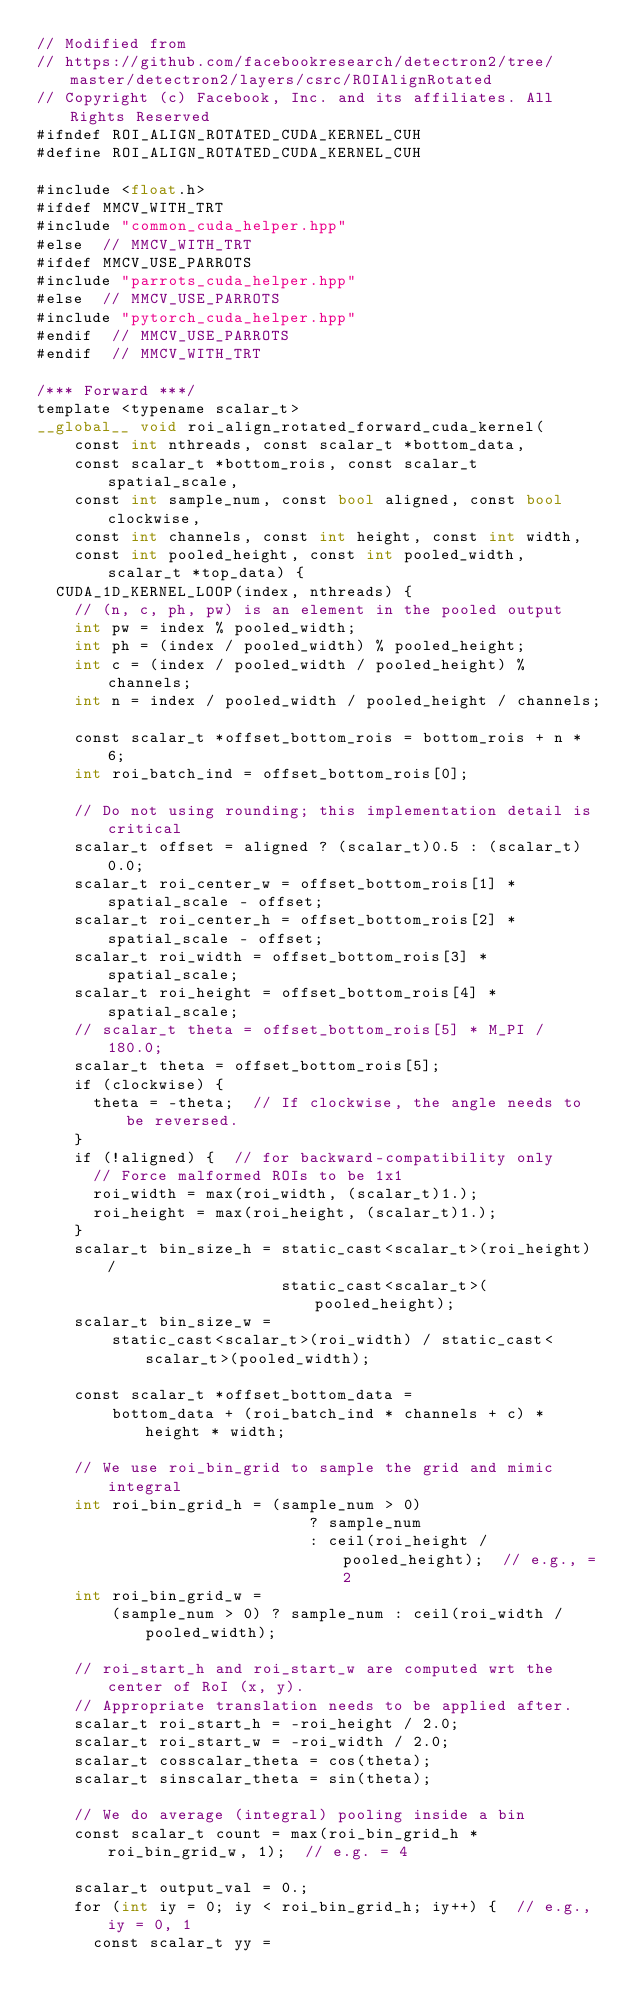Convert code to text. <code><loc_0><loc_0><loc_500><loc_500><_Cuda_>// Modified from
// https://github.com/facebookresearch/detectron2/tree/master/detectron2/layers/csrc/ROIAlignRotated
// Copyright (c) Facebook, Inc. and its affiliates. All Rights Reserved
#ifndef ROI_ALIGN_ROTATED_CUDA_KERNEL_CUH
#define ROI_ALIGN_ROTATED_CUDA_KERNEL_CUH

#include <float.h>
#ifdef MMCV_WITH_TRT
#include "common_cuda_helper.hpp"
#else  // MMCV_WITH_TRT
#ifdef MMCV_USE_PARROTS
#include "parrots_cuda_helper.hpp"
#else  // MMCV_USE_PARROTS
#include "pytorch_cuda_helper.hpp"
#endif  // MMCV_USE_PARROTS
#endif  // MMCV_WITH_TRT

/*** Forward ***/
template <typename scalar_t>
__global__ void roi_align_rotated_forward_cuda_kernel(
    const int nthreads, const scalar_t *bottom_data,
    const scalar_t *bottom_rois, const scalar_t spatial_scale,
    const int sample_num, const bool aligned, const bool clockwise,
    const int channels, const int height, const int width,
    const int pooled_height, const int pooled_width, scalar_t *top_data) {
  CUDA_1D_KERNEL_LOOP(index, nthreads) {
    // (n, c, ph, pw) is an element in the pooled output
    int pw = index % pooled_width;
    int ph = (index / pooled_width) % pooled_height;
    int c = (index / pooled_width / pooled_height) % channels;
    int n = index / pooled_width / pooled_height / channels;

    const scalar_t *offset_bottom_rois = bottom_rois + n * 6;
    int roi_batch_ind = offset_bottom_rois[0];

    // Do not using rounding; this implementation detail is critical
    scalar_t offset = aligned ? (scalar_t)0.5 : (scalar_t)0.0;
    scalar_t roi_center_w = offset_bottom_rois[1] * spatial_scale - offset;
    scalar_t roi_center_h = offset_bottom_rois[2] * spatial_scale - offset;
    scalar_t roi_width = offset_bottom_rois[3] * spatial_scale;
    scalar_t roi_height = offset_bottom_rois[4] * spatial_scale;
    // scalar_t theta = offset_bottom_rois[5] * M_PI / 180.0;
    scalar_t theta = offset_bottom_rois[5];
    if (clockwise) {
      theta = -theta;  // If clockwise, the angle needs to be reversed.
    }
    if (!aligned) {  // for backward-compatibility only
      // Force malformed ROIs to be 1x1
      roi_width = max(roi_width, (scalar_t)1.);
      roi_height = max(roi_height, (scalar_t)1.);
    }
    scalar_t bin_size_h = static_cast<scalar_t>(roi_height) /
                          static_cast<scalar_t>(pooled_height);
    scalar_t bin_size_w =
        static_cast<scalar_t>(roi_width) / static_cast<scalar_t>(pooled_width);

    const scalar_t *offset_bottom_data =
        bottom_data + (roi_batch_ind * channels + c) * height * width;

    // We use roi_bin_grid to sample the grid and mimic integral
    int roi_bin_grid_h = (sample_num > 0)
                             ? sample_num
                             : ceil(roi_height / pooled_height);  // e.g., = 2
    int roi_bin_grid_w =
        (sample_num > 0) ? sample_num : ceil(roi_width / pooled_width);

    // roi_start_h and roi_start_w are computed wrt the center of RoI (x, y).
    // Appropriate translation needs to be applied after.
    scalar_t roi_start_h = -roi_height / 2.0;
    scalar_t roi_start_w = -roi_width / 2.0;
    scalar_t cosscalar_theta = cos(theta);
    scalar_t sinscalar_theta = sin(theta);

    // We do average (integral) pooling inside a bin
    const scalar_t count = max(roi_bin_grid_h * roi_bin_grid_w, 1);  // e.g. = 4

    scalar_t output_val = 0.;
    for (int iy = 0; iy < roi_bin_grid_h; iy++) {  // e.g., iy = 0, 1
      const scalar_t yy =</code> 